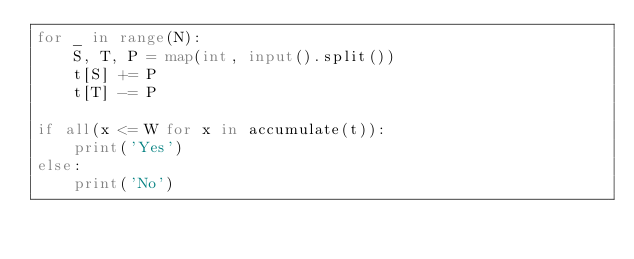<code> <loc_0><loc_0><loc_500><loc_500><_Python_>for _ in range(N):
    S, T, P = map(int, input().split())
    t[S] += P
    t[T] -= P

if all(x <= W for x in accumulate(t)):
    print('Yes')
else:
    print('No')
</code> 